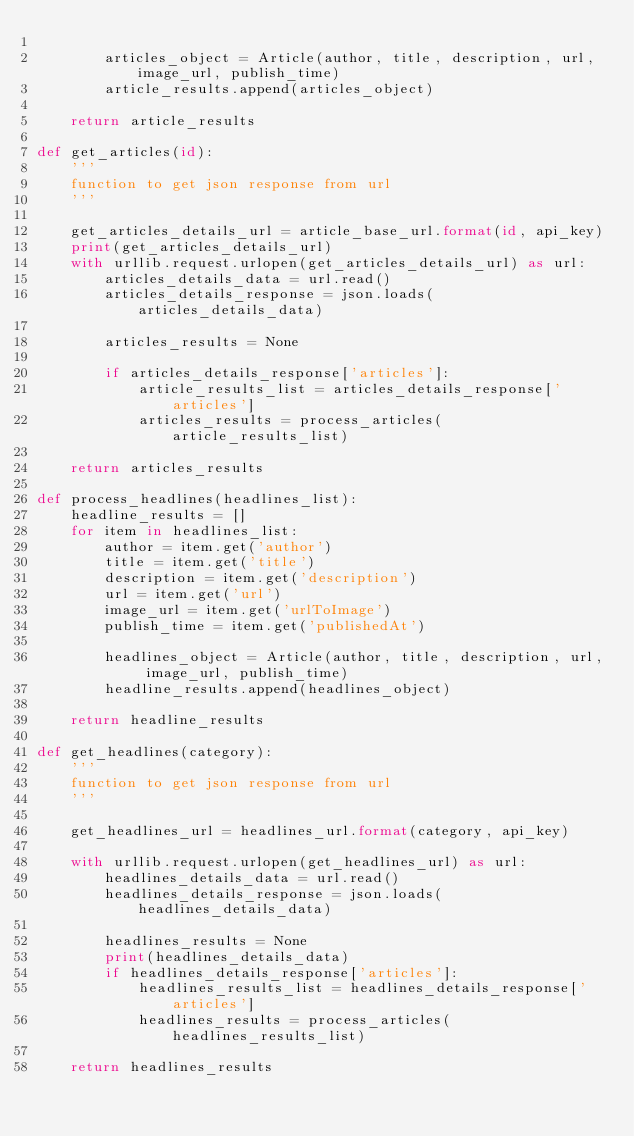Convert code to text. <code><loc_0><loc_0><loc_500><loc_500><_Python_>
        articles_object = Article(author, title, description, url, image_url, publish_time)
        article_results.append(articles_object)

    return article_results
            
def get_articles(id):
    '''
    function to get json response from url
    '''
  
    get_articles_details_url = article_base_url.format(id, api_key)
    print(get_articles_details_url)
    with urllib.request.urlopen(get_articles_details_url) as url:
        articles_details_data = url.read()
        articles_details_response = json.loads(articles_details_data)

        articles_results = None
    
        if articles_details_response['articles']:
            article_results_list = articles_details_response['articles']
            articles_results = process_articles(article_results_list)
    
    return articles_results

def process_headlines(headlines_list):
    headline_results = []
    for item in headlines_list:
        author = item.get('author')
        title = item.get('title')
        description = item.get('description')
        url = item.get('url')
        image_url = item.get('urlToImage')
        publish_time = item.get('publishedAt')

        headlines_object = Article(author, title, description, url, image_url, publish_time)
        headline_results.append(headlines_object)

    return headline_results
            
def get_headlines(category):
    '''
    function to get json response from url
    '''
    
    get_headlines_url = headlines_url.format(category, api_key)

    with urllib.request.urlopen(get_headlines_url) as url:
        headlines_details_data = url.read()
        headlines_details_response = json.loads(headlines_details_data)

        headlines_results = None
        print(headlines_details_data)
        if headlines_details_response['articles']:
            headlines_results_list = headlines_details_response['articles']
            headlines_results = process_articles(headlines_results_list)
    
    return headlines_results
</code> 